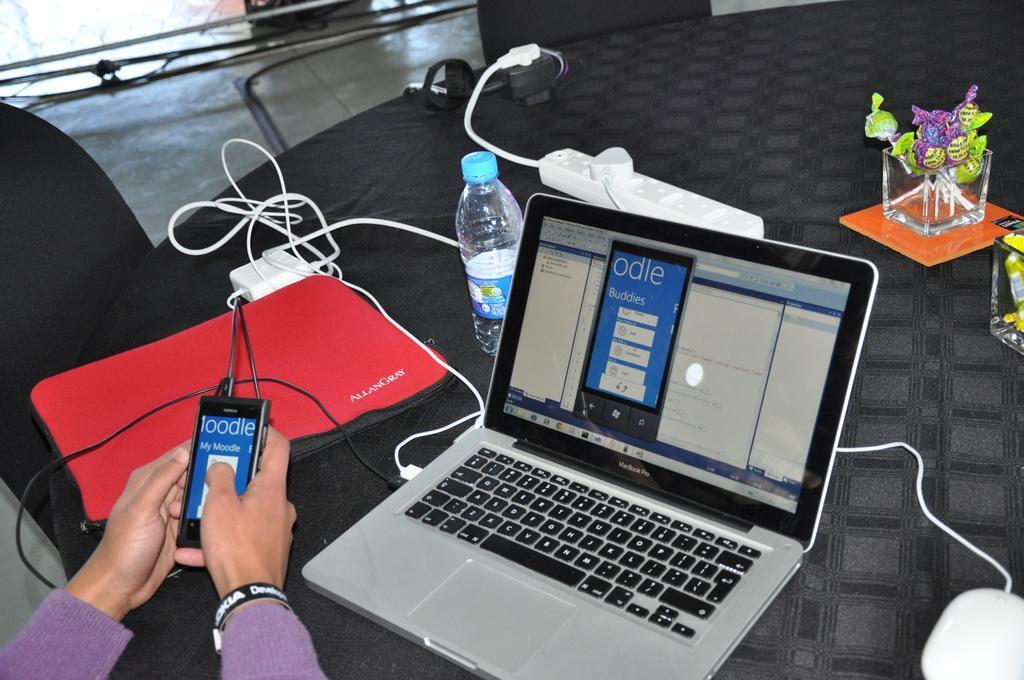Can you describe this image briefly? In this picture there is a table on the right side of the image and there are chairs on the left side of the image, table contains water bottle, wires, and a laptop, there is a lady who is operating the phone at the bottom left side of the image. 